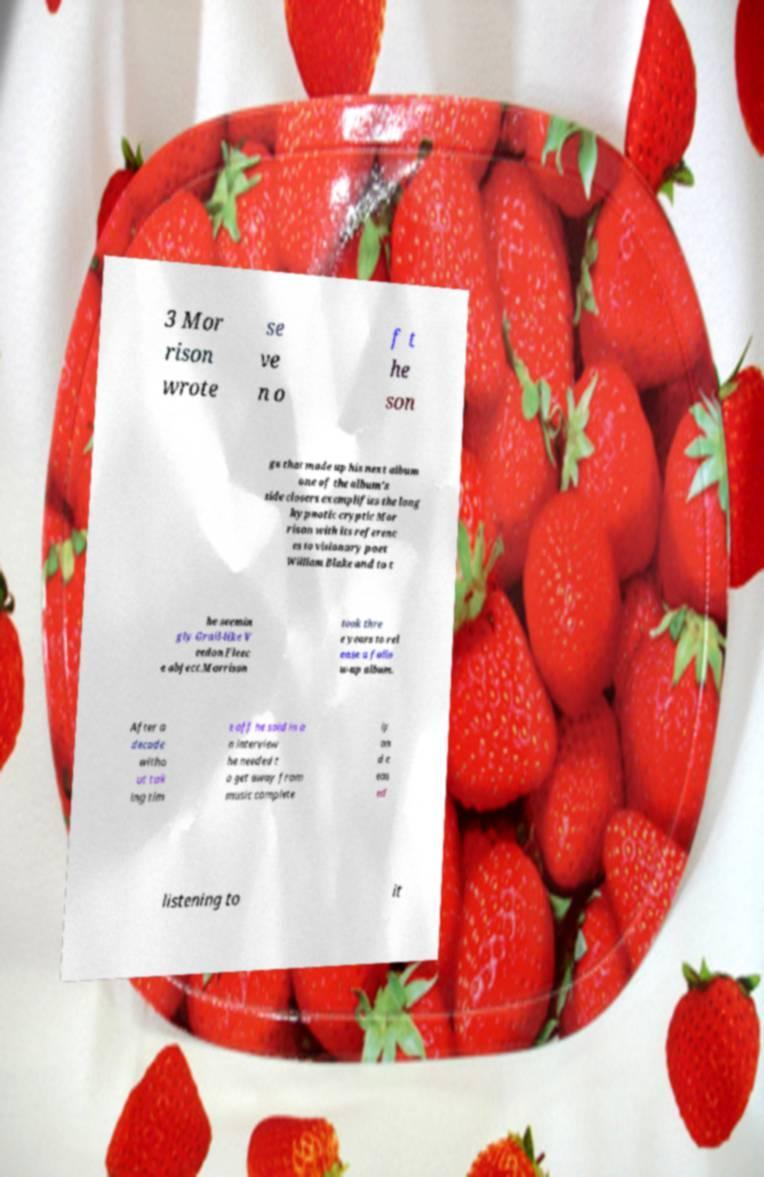There's text embedded in this image that I need extracted. Can you transcribe it verbatim? 3 Mor rison wrote se ve n o f t he son gs that made up his next album one of the album's side closers exemplifies the long hypnotic cryptic Mor rison with its referenc es to visionary poet William Blake and to t he seemin gly Grail-like V eedon Fleec e object.Morrison took thre e years to rel ease a follo w-up album. After a decade witho ut tak ing tim e off he said in a n interview he needed t o get away from music complete ly an d c eas ed listening to it 